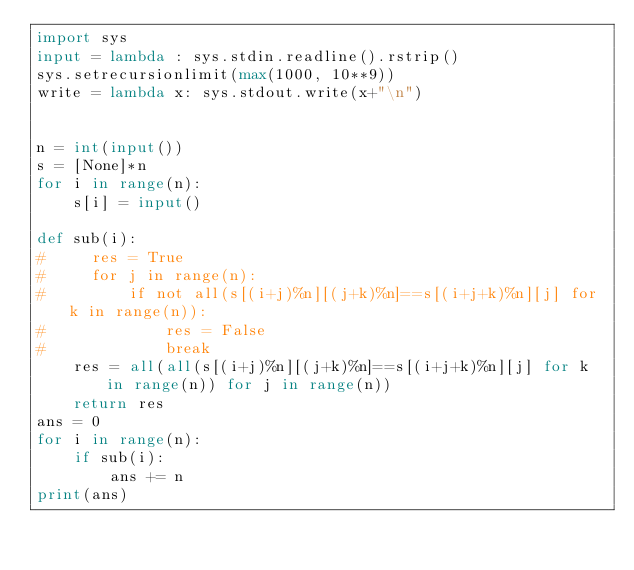Convert code to text. <code><loc_0><loc_0><loc_500><loc_500><_Python_>import sys
input = lambda : sys.stdin.readline().rstrip()
sys.setrecursionlimit(max(1000, 10**9))
write = lambda x: sys.stdout.write(x+"\n")


n = int(input())
s = [None]*n
for i in range(n):
    s[i] = input()
    
def sub(i):
#     res = True
#     for j in range(n):
#         if not all(s[(i+j)%n][(j+k)%n]==s[(i+j+k)%n][j] for k in range(n)):
#             res = False
#             break
    res = all(all(s[(i+j)%n][(j+k)%n]==s[(i+j+k)%n][j] for k in range(n)) for j in range(n))
    return res
ans = 0
for i in range(n):
    if sub(i):
        ans += n
print(ans)</code> 